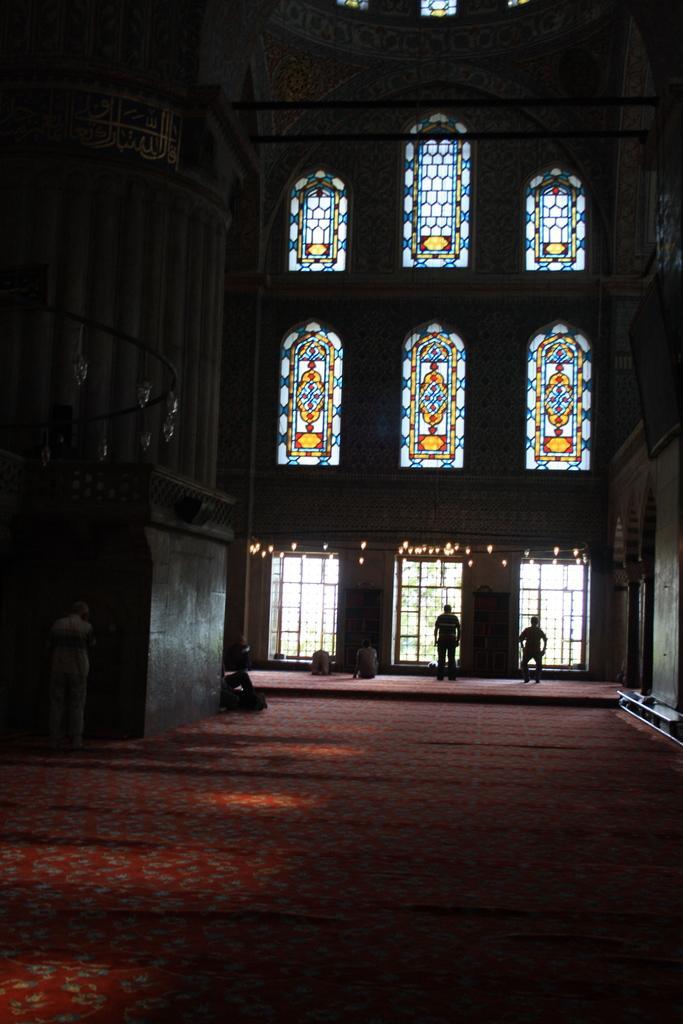Describe this image in one or two sentences. In this image, we can see the carpet on the floor, there are some persons standing and we can see some windows. 